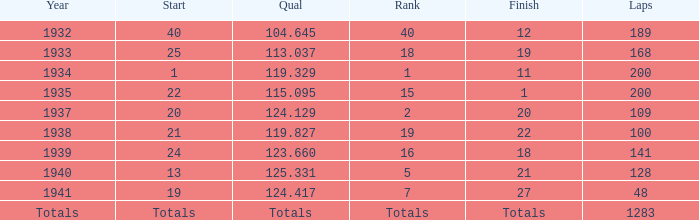What was the finish place with a qual of 123.660? 18.0. 